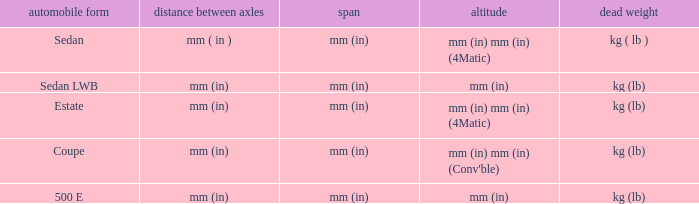What's the length of the model with Sedan body style? Mm (in). 